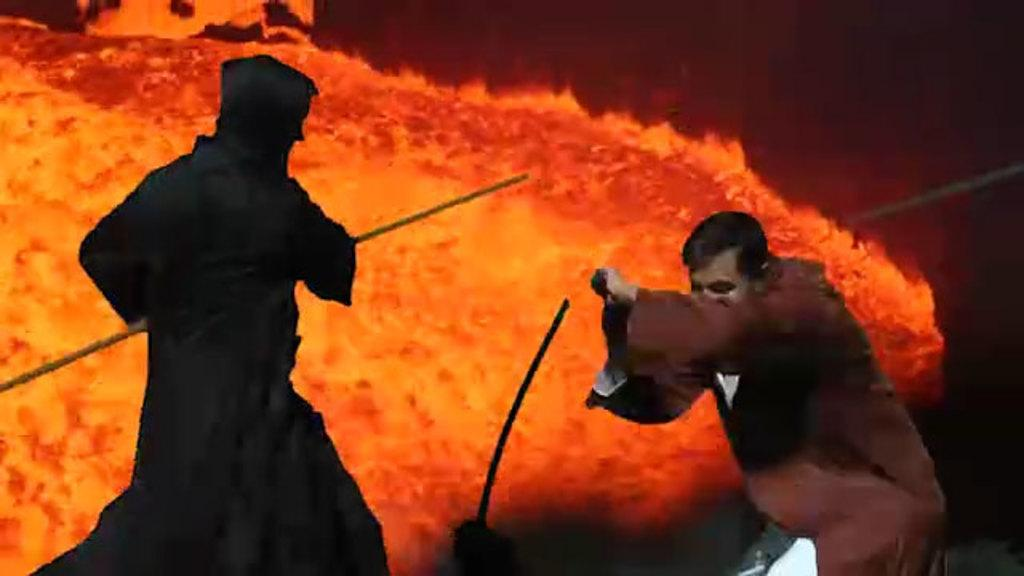How many people are in the image? There are two persons in the front of the image. What is one person holding in the image? One person is holding a stick. Where is the person on the left side of the image located? The person on the left side of the image is in the front. What can be seen in the background of the image? There is fire visible in the background of the image. What type of art is displayed on the scale in the image? There is no scale or art present in the image. Is the ring visible on the person's finger in the image? There is no ring visible on any person's finger in the image. 